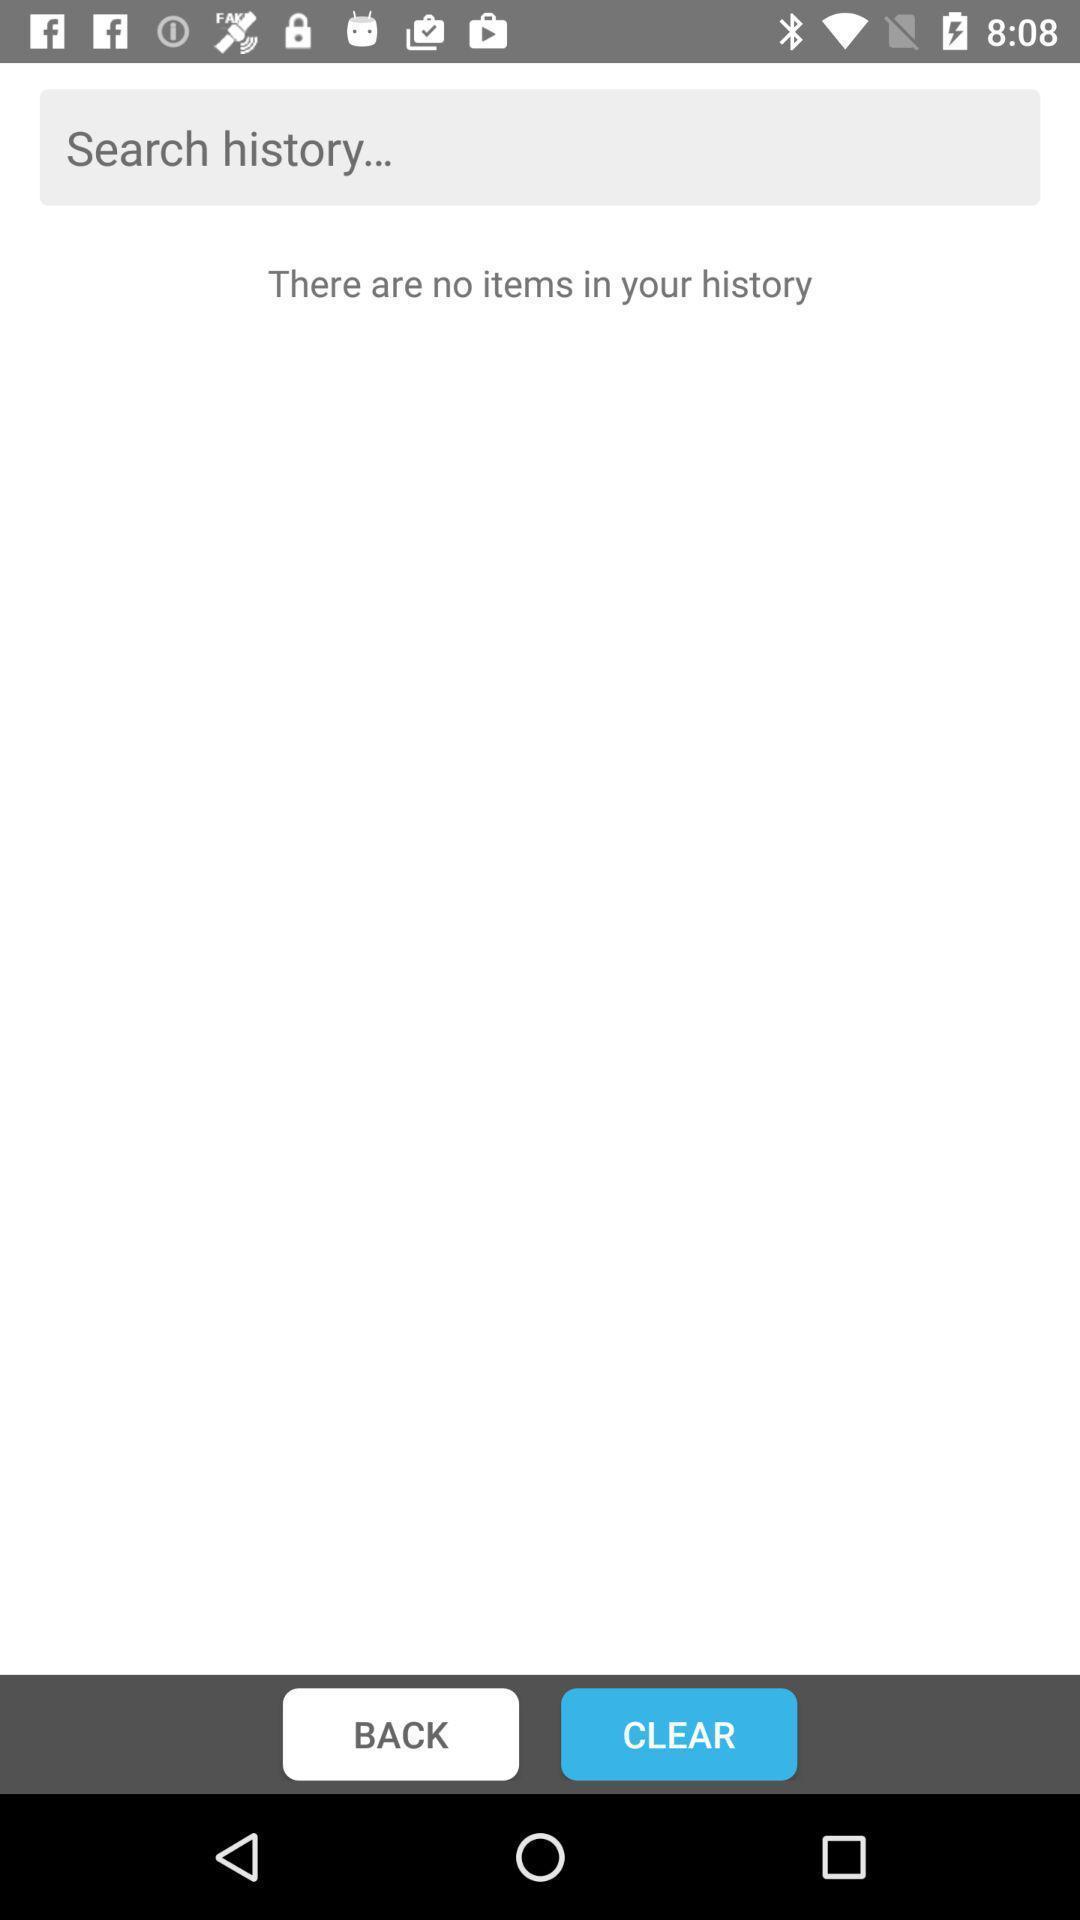What is the overall content of this screenshot? Screen displaying multiple options and a search bar. 